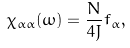<formula> <loc_0><loc_0><loc_500><loc_500>\chi _ { \alpha \alpha } ( \omega ) = \frac { N } { 4 J } f _ { \alpha } ,</formula> 